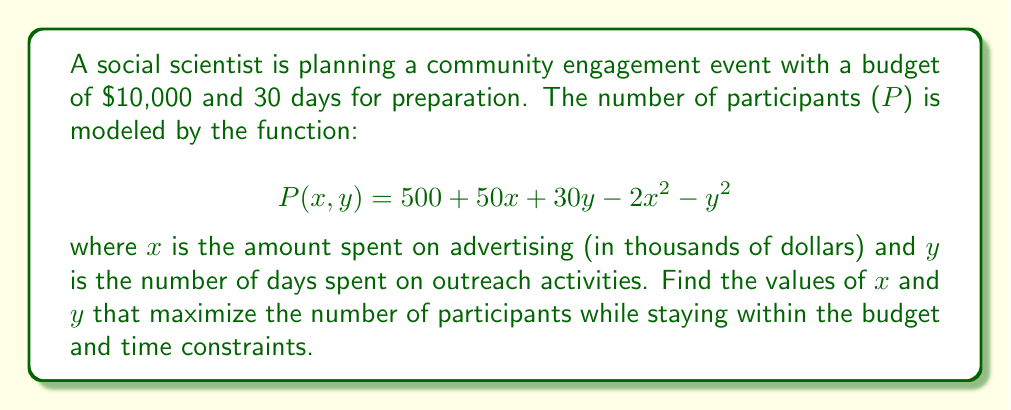Can you solve this math problem? To solve this optimization problem with constraints, we'll use the method of Lagrange multipliers.

1) First, let's define our constraints:
   $x + y \leq 10$ (budget constraint)
   $y \leq 30$ (time constraint)

2) We'll focus on the budget constraint as it's more likely to be binding. Our Lagrangian function is:

   $$L(x, y, \lambda) = 500 + 50x + 30y - 2x^2 - y^2 + \lambda(10 - x - y)$$

3) Now, we take partial derivatives and set them to zero:

   $$\frac{\partial L}{\partial x} = 50 - 4x - \lambda = 0$$
   $$\frac{\partial L}{\partial y} = 30 - 2y - \lambda = 0$$
   $$\frac{\partial L}{\partial \lambda} = 10 - x - y = 0$$

4) From the first two equations:
   $50 - 4x = \lambda$ and $30 - 2y = \lambda$

5) Equating these:
   $50 - 4x = 30 - 2y$
   $20 = 4x - 2y$
   $10 = 2x - y$

6) Substituting this into the constraint equation:
   $10 - x - y = 0$
   $10 - x - (2x - 10) = 0$
   $20 - 3x = 0$
   $x = \frac{20}{3}$

7) Substituting back:
   $y = 2x - 10 = 2(\frac{20}{3}) - 10 = \frac{40}{3} - 10 = \frac{10}{3}$

8) Checking the time constraint:
   $\frac{10}{3} < 30$, so this constraint is satisfied.

9) The maximum number of participants is:
   $$P(\frac{20}{3}, \frac{10}{3}) = 500 + 50(\frac{20}{3}) + 30(\frac{10}{3}) - 2(\frac{20}{3})^2 - (\frac{10}{3})^2$$
   $$= 500 + \frac{1000}{3} + 100 - \frac{800}{9} - \frac{100}{9} = 500 + \frac{3000}{9} + \frac{900}{9} - \frac{900}{9} = 500 + \frac{3000}{9} = 833.33$$
Answer: The maximum number of participants is achieved when $x = \frac{20}{3}$ thousand dollars (approximately $6,667) is spent on advertising and $y = \frac{10}{3}$ days (approximately 3.33 days) are spent on outreach activities. This results in a maximum of approximately 833 participants. 